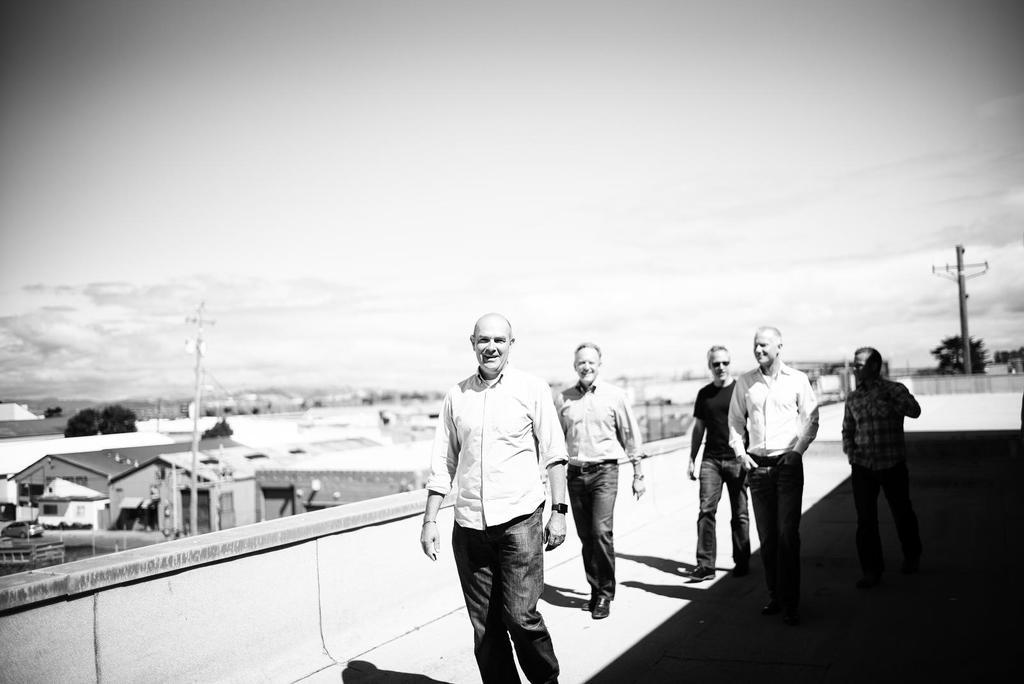What is the color scheme of the image? The image is black and white. How many men are present in the image? There are six men in the image. What are the men doing in the image? The men are walking on a building. What can be seen in the background of the image? There are houses and the sky visible in the background of the image. What type of school can be seen in the image? There is no school present in the image; it features six men walking on a building with houses and the sky in the background. What type of expansion is taking place in the image? There is no expansion taking place in the image; it simply shows six men walking on a building with houses and the sky in the background. 